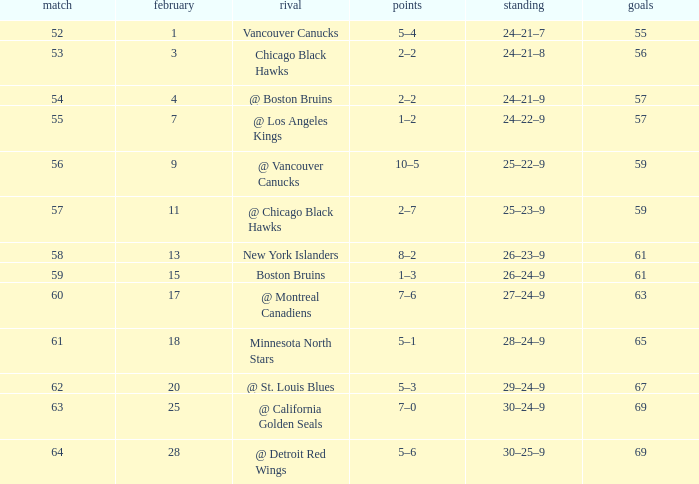How many games have a record of 30–25–9 and more points than 69? 0.0. 